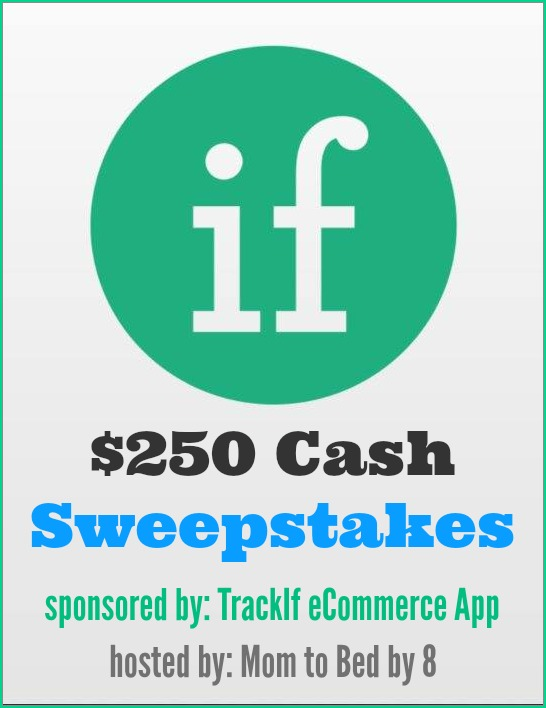How could the partnership between TrackIf eCommerce App and 'Mom to Bed by 8' reflect a larger trend in digital marketing strategies? The partnership between TrackIf eCommerce App and 'Mom to Bed by 8' is indicative of a larger trend in digital marketing strategies where businesses collaborate with niche influencers and content creators to reach targeted audiences. In this case, TrackIf aligns with 'Mom to Bed by 8' to tap into a community of parents and families, demonstrating a shift towards personalized and community-centric marketing. This trend reflects the understanding that consumers are more likely to trust and engage with content that resonates with their lifestyle and interests, especially when it is presented by trusted sources within their community. 